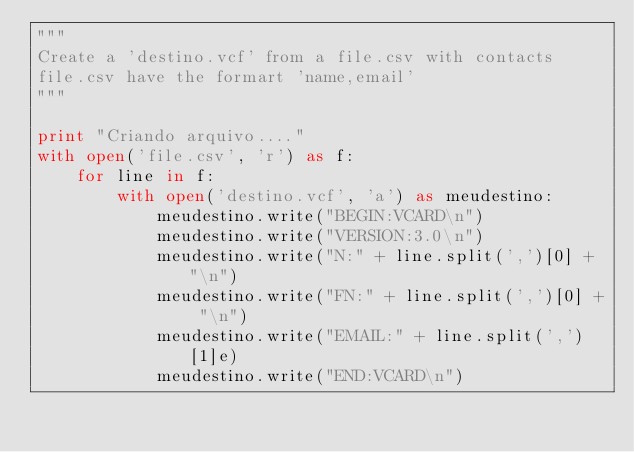Convert code to text. <code><loc_0><loc_0><loc_500><loc_500><_Python_>"""
Create a 'destino.vcf' from a file.csv with contacts
file.csv have the formart 'name,email'
"""

print "Criando arquivo...."
with open('file.csv', 'r') as f:
    for line in f:
        with open('destino.vcf', 'a') as meudestino:
            meudestino.write("BEGIN:VCARD\n")
            meudestino.write("VERSION:3.0\n")
            meudestino.write("N:" + line.split(',')[0] + "\n")
            meudestino.write("FN:" + line.split(',')[0] + "\n")
            meudestino.write("EMAIL:" + line.split(',')[1]e)
            meudestino.write("END:VCARD\n")
</code> 